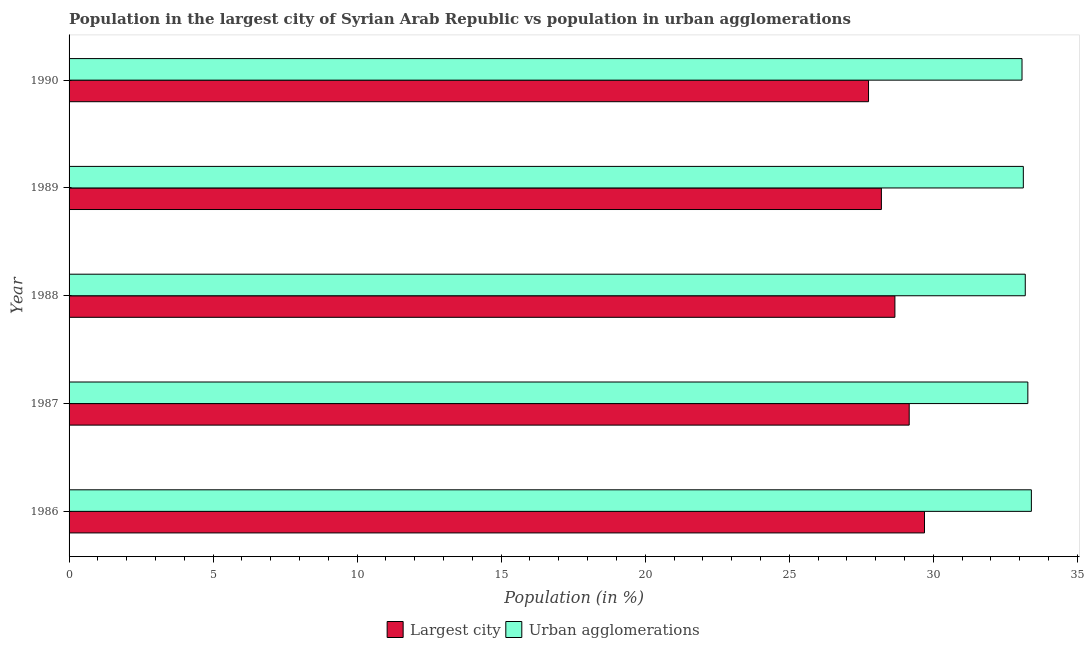How many groups of bars are there?
Provide a short and direct response. 5. Are the number of bars per tick equal to the number of legend labels?
Your answer should be compact. Yes. How many bars are there on the 5th tick from the top?
Offer a very short reply. 2. What is the label of the 2nd group of bars from the top?
Give a very brief answer. 1989. In how many cases, is the number of bars for a given year not equal to the number of legend labels?
Your answer should be compact. 0. What is the population in the largest city in 1986?
Offer a terse response. 29.7. Across all years, what is the maximum population in urban agglomerations?
Provide a succinct answer. 33.41. Across all years, what is the minimum population in urban agglomerations?
Offer a very short reply. 33.08. What is the total population in the largest city in the graph?
Provide a short and direct response. 143.48. What is the difference between the population in the largest city in 1987 and that in 1989?
Give a very brief answer. 0.97. What is the difference between the population in the largest city in 1990 and the population in urban agglomerations in 1988?
Your answer should be very brief. -5.44. What is the average population in the largest city per year?
Offer a terse response. 28.7. In the year 1987, what is the difference between the population in the largest city and population in urban agglomerations?
Your answer should be compact. -4.12. In how many years, is the population in the largest city greater than 16 %?
Keep it short and to the point. 5. What is the difference between the highest and the second highest population in urban agglomerations?
Make the answer very short. 0.12. What is the difference between the highest and the lowest population in the largest city?
Offer a terse response. 1.94. What does the 1st bar from the top in 1989 represents?
Make the answer very short. Urban agglomerations. What does the 2nd bar from the bottom in 1990 represents?
Offer a terse response. Urban agglomerations. Are all the bars in the graph horizontal?
Provide a short and direct response. Yes. How many years are there in the graph?
Your answer should be compact. 5. Does the graph contain any zero values?
Give a very brief answer. No. Does the graph contain grids?
Your answer should be very brief. No. Where does the legend appear in the graph?
Provide a short and direct response. Bottom center. How are the legend labels stacked?
Provide a succinct answer. Horizontal. What is the title of the graph?
Keep it short and to the point. Population in the largest city of Syrian Arab Republic vs population in urban agglomerations. Does "External balance on goods" appear as one of the legend labels in the graph?
Your answer should be compact. No. What is the label or title of the Y-axis?
Your answer should be compact. Year. What is the Population (in %) in Largest city in 1986?
Your answer should be very brief. 29.7. What is the Population (in %) of Urban agglomerations in 1986?
Provide a succinct answer. 33.41. What is the Population (in %) of Largest city in 1987?
Make the answer very short. 29.16. What is the Population (in %) in Urban agglomerations in 1987?
Provide a short and direct response. 33.28. What is the Population (in %) in Largest city in 1988?
Your answer should be very brief. 28.67. What is the Population (in %) in Urban agglomerations in 1988?
Your response must be concise. 33.19. What is the Population (in %) of Largest city in 1989?
Provide a short and direct response. 28.2. What is the Population (in %) in Urban agglomerations in 1989?
Ensure brevity in your answer.  33.13. What is the Population (in %) in Largest city in 1990?
Provide a succinct answer. 27.75. What is the Population (in %) of Urban agglomerations in 1990?
Ensure brevity in your answer.  33.08. Across all years, what is the maximum Population (in %) in Largest city?
Give a very brief answer. 29.7. Across all years, what is the maximum Population (in %) in Urban agglomerations?
Keep it short and to the point. 33.41. Across all years, what is the minimum Population (in %) of Largest city?
Provide a short and direct response. 27.75. Across all years, what is the minimum Population (in %) of Urban agglomerations?
Provide a succinct answer. 33.08. What is the total Population (in %) in Largest city in the graph?
Give a very brief answer. 143.48. What is the total Population (in %) in Urban agglomerations in the graph?
Offer a terse response. 166.09. What is the difference between the Population (in %) of Largest city in 1986 and that in 1987?
Give a very brief answer. 0.53. What is the difference between the Population (in %) in Urban agglomerations in 1986 and that in 1987?
Provide a short and direct response. 0.12. What is the difference between the Population (in %) of Urban agglomerations in 1986 and that in 1988?
Keep it short and to the point. 0.21. What is the difference between the Population (in %) in Largest city in 1986 and that in 1989?
Your response must be concise. 1.5. What is the difference between the Population (in %) in Urban agglomerations in 1986 and that in 1989?
Offer a terse response. 0.28. What is the difference between the Population (in %) of Largest city in 1986 and that in 1990?
Provide a succinct answer. 1.94. What is the difference between the Population (in %) in Urban agglomerations in 1986 and that in 1990?
Provide a short and direct response. 0.33. What is the difference between the Population (in %) of Largest city in 1987 and that in 1988?
Your answer should be very brief. 0.5. What is the difference between the Population (in %) of Urban agglomerations in 1987 and that in 1988?
Offer a very short reply. 0.09. What is the difference between the Population (in %) of Largest city in 1987 and that in 1989?
Your answer should be compact. 0.97. What is the difference between the Population (in %) in Urban agglomerations in 1987 and that in 1989?
Provide a succinct answer. 0.16. What is the difference between the Population (in %) in Largest city in 1987 and that in 1990?
Your response must be concise. 1.41. What is the difference between the Population (in %) of Urban agglomerations in 1987 and that in 1990?
Make the answer very short. 0.2. What is the difference between the Population (in %) of Largest city in 1988 and that in 1989?
Your answer should be very brief. 0.47. What is the difference between the Population (in %) of Urban agglomerations in 1988 and that in 1989?
Ensure brevity in your answer.  0.07. What is the difference between the Population (in %) in Largest city in 1988 and that in 1990?
Your answer should be compact. 0.92. What is the difference between the Population (in %) of Urban agglomerations in 1988 and that in 1990?
Your answer should be compact. 0.11. What is the difference between the Population (in %) in Largest city in 1989 and that in 1990?
Make the answer very short. 0.45. What is the difference between the Population (in %) in Urban agglomerations in 1989 and that in 1990?
Your answer should be compact. 0.05. What is the difference between the Population (in %) of Largest city in 1986 and the Population (in %) of Urban agglomerations in 1987?
Give a very brief answer. -3.59. What is the difference between the Population (in %) in Largest city in 1986 and the Population (in %) in Urban agglomerations in 1988?
Your answer should be very brief. -3.5. What is the difference between the Population (in %) in Largest city in 1986 and the Population (in %) in Urban agglomerations in 1989?
Your response must be concise. -3.43. What is the difference between the Population (in %) of Largest city in 1986 and the Population (in %) of Urban agglomerations in 1990?
Your answer should be compact. -3.39. What is the difference between the Population (in %) in Largest city in 1987 and the Population (in %) in Urban agglomerations in 1988?
Ensure brevity in your answer.  -4.03. What is the difference between the Population (in %) in Largest city in 1987 and the Population (in %) in Urban agglomerations in 1989?
Ensure brevity in your answer.  -3.96. What is the difference between the Population (in %) of Largest city in 1987 and the Population (in %) of Urban agglomerations in 1990?
Ensure brevity in your answer.  -3.92. What is the difference between the Population (in %) in Largest city in 1988 and the Population (in %) in Urban agglomerations in 1989?
Your answer should be very brief. -4.46. What is the difference between the Population (in %) of Largest city in 1988 and the Population (in %) of Urban agglomerations in 1990?
Your response must be concise. -4.41. What is the difference between the Population (in %) in Largest city in 1989 and the Population (in %) in Urban agglomerations in 1990?
Your answer should be compact. -4.88. What is the average Population (in %) in Largest city per year?
Provide a short and direct response. 28.7. What is the average Population (in %) in Urban agglomerations per year?
Your answer should be compact. 33.22. In the year 1986, what is the difference between the Population (in %) in Largest city and Population (in %) in Urban agglomerations?
Offer a terse response. -3.71. In the year 1987, what is the difference between the Population (in %) in Largest city and Population (in %) in Urban agglomerations?
Your answer should be very brief. -4.12. In the year 1988, what is the difference between the Population (in %) in Largest city and Population (in %) in Urban agglomerations?
Give a very brief answer. -4.53. In the year 1989, what is the difference between the Population (in %) in Largest city and Population (in %) in Urban agglomerations?
Your answer should be very brief. -4.93. In the year 1990, what is the difference between the Population (in %) in Largest city and Population (in %) in Urban agglomerations?
Your answer should be very brief. -5.33. What is the ratio of the Population (in %) of Largest city in 1986 to that in 1987?
Your answer should be compact. 1.02. What is the ratio of the Population (in %) of Urban agglomerations in 1986 to that in 1987?
Make the answer very short. 1. What is the ratio of the Population (in %) of Largest city in 1986 to that in 1988?
Ensure brevity in your answer.  1.04. What is the ratio of the Population (in %) of Urban agglomerations in 1986 to that in 1988?
Make the answer very short. 1.01. What is the ratio of the Population (in %) in Largest city in 1986 to that in 1989?
Provide a succinct answer. 1.05. What is the ratio of the Population (in %) of Urban agglomerations in 1986 to that in 1989?
Keep it short and to the point. 1.01. What is the ratio of the Population (in %) in Largest city in 1986 to that in 1990?
Keep it short and to the point. 1.07. What is the ratio of the Population (in %) of Urban agglomerations in 1986 to that in 1990?
Offer a terse response. 1.01. What is the ratio of the Population (in %) in Largest city in 1987 to that in 1988?
Offer a very short reply. 1.02. What is the ratio of the Population (in %) in Urban agglomerations in 1987 to that in 1988?
Offer a terse response. 1. What is the ratio of the Population (in %) in Largest city in 1987 to that in 1989?
Your response must be concise. 1.03. What is the ratio of the Population (in %) of Urban agglomerations in 1987 to that in 1989?
Give a very brief answer. 1. What is the ratio of the Population (in %) of Largest city in 1987 to that in 1990?
Give a very brief answer. 1.05. What is the ratio of the Population (in %) of Urban agglomerations in 1987 to that in 1990?
Provide a succinct answer. 1.01. What is the ratio of the Population (in %) of Largest city in 1988 to that in 1989?
Your answer should be compact. 1.02. What is the ratio of the Population (in %) in Largest city in 1988 to that in 1990?
Offer a very short reply. 1.03. What is the ratio of the Population (in %) of Urban agglomerations in 1988 to that in 1990?
Provide a succinct answer. 1. What is the ratio of the Population (in %) of Largest city in 1989 to that in 1990?
Your response must be concise. 1.02. What is the difference between the highest and the second highest Population (in %) in Largest city?
Your response must be concise. 0.53. What is the difference between the highest and the second highest Population (in %) of Urban agglomerations?
Ensure brevity in your answer.  0.12. What is the difference between the highest and the lowest Population (in %) of Largest city?
Make the answer very short. 1.94. What is the difference between the highest and the lowest Population (in %) of Urban agglomerations?
Offer a terse response. 0.33. 